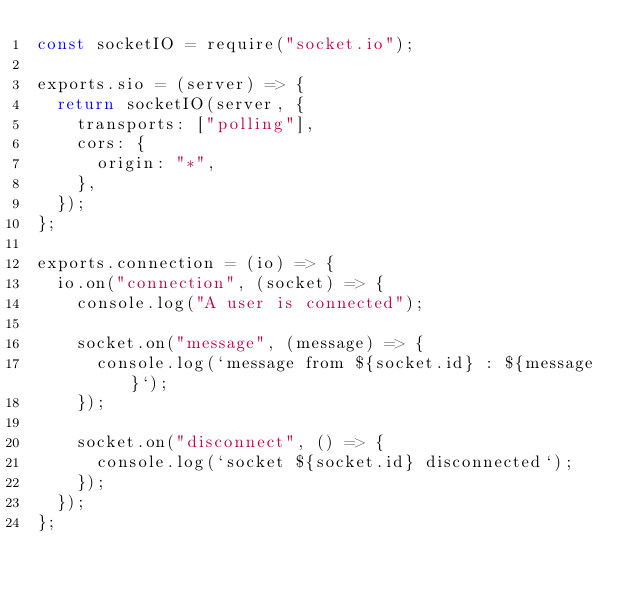<code> <loc_0><loc_0><loc_500><loc_500><_JavaScript_>const socketIO = require("socket.io");

exports.sio = (server) => {
  return socketIO(server, {
    transports: ["polling"],
    cors: {
      origin: "*",
    },
  });
};

exports.connection = (io) => {
  io.on("connection", (socket) => {
    console.log("A user is connected");

    socket.on("message", (message) => {
      console.log(`message from ${socket.id} : ${message}`);
    });

    socket.on("disconnect", () => {
      console.log(`socket ${socket.id} disconnected`);
    });
  });
};
</code> 